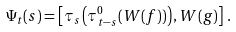<formula> <loc_0><loc_0><loc_500><loc_500>\Psi _ { t } ( s ) = \left [ \tau _ { s } \left ( \tau _ { t - s } ^ { 0 } ( W ( f ) ) \right ) , W ( g ) \right ] \, .</formula> 